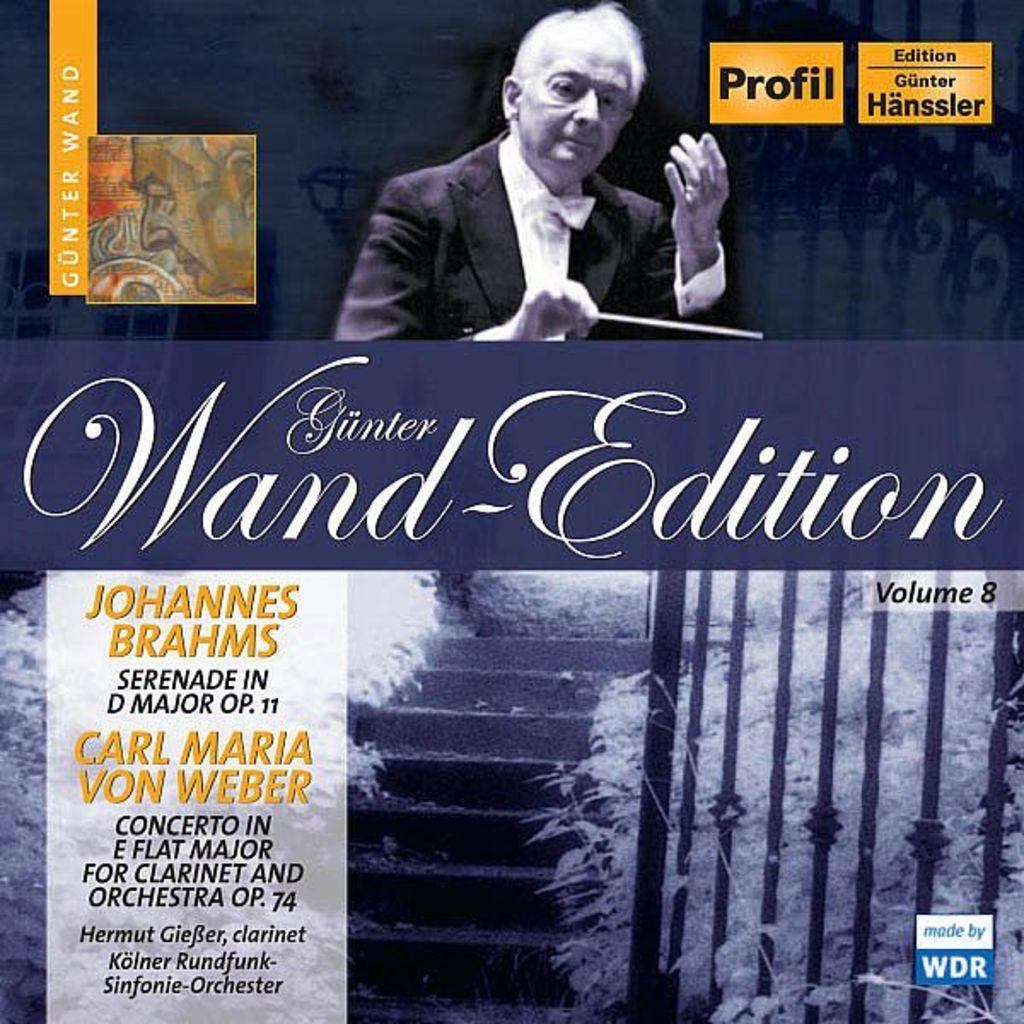<image>
Provide a brief description of the given image. A classical music recording featuring both a Brahms and a Carl Maria von Weber piece. 